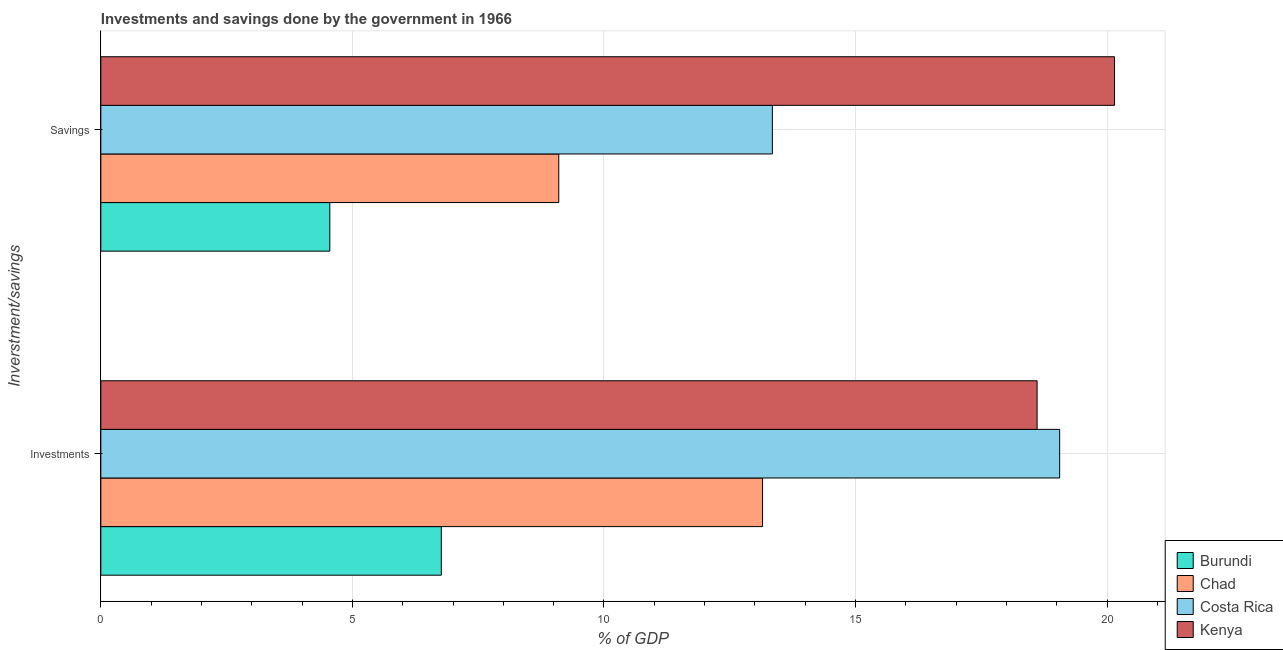How many different coloured bars are there?
Keep it short and to the point. 4. Are the number of bars per tick equal to the number of legend labels?
Keep it short and to the point. Yes. Are the number of bars on each tick of the Y-axis equal?
Provide a succinct answer. Yes. How many bars are there on the 1st tick from the bottom?
Make the answer very short. 4. What is the label of the 2nd group of bars from the top?
Offer a very short reply. Investments. What is the savings of government in Burundi?
Your response must be concise. 4.55. Across all countries, what is the maximum investments of government?
Offer a terse response. 19.06. Across all countries, what is the minimum investments of government?
Make the answer very short. 6.77. In which country was the investments of government maximum?
Your answer should be very brief. Costa Rica. In which country was the savings of government minimum?
Ensure brevity in your answer.  Burundi. What is the total investments of government in the graph?
Offer a very short reply. 57.59. What is the difference between the investments of government in Kenya and that in Burundi?
Give a very brief answer. 11.84. What is the difference between the investments of government in Burundi and the savings of government in Kenya?
Offer a very short reply. -13.38. What is the average investments of government per country?
Give a very brief answer. 14.4. What is the difference between the investments of government and savings of government in Kenya?
Give a very brief answer. -1.54. In how many countries, is the savings of government greater than 19 %?
Provide a short and direct response. 1. What is the ratio of the savings of government in Costa Rica to that in Burundi?
Your answer should be very brief. 2.93. What does the 4th bar from the top in Savings represents?
Ensure brevity in your answer.  Burundi. What does the 4th bar from the bottom in Savings represents?
Provide a short and direct response. Kenya. How many countries are there in the graph?
Your response must be concise. 4. What is the difference between two consecutive major ticks on the X-axis?
Offer a terse response. 5. Where does the legend appear in the graph?
Your answer should be compact. Bottom right. How many legend labels are there?
Your answer should be compact. 4. What is the title of the graph?
Provide a succinct answer. Investments and savings done by the government in 1966. What is the label or title of the X-axis?
Ensure brevity in your answer.  % of GDP. What is the label or title of the Y-axis?
Give a very brief answer. Inverstment/savings. What is the % of GDP of Burundi in Investments?
Your answer should be very brief. 6.77. What is the % of GDP of Chad in Investments?
Your response must be concise. 13.15. What is the % of GDP of Costa Rica in Investments?
Offer a very short reply. 19.06. What is the % of GDP of Kenya in Investments?
Your answer should be very brief. 18.61. What is the % of GDP of Burundi in Savings?
Provide a succinct answer. 4.55. What is the % of GDP in Chad in Savings?
Provide a succinct answer. 9.1. What is the % of GDP in Costa Rica in Savings?
Offer a very short reply. 13.35. What is the % of GDP of Kenya in Savings?
Your answer should be compact. 20.15. Across all Inverstment/savings, what is the maximum % of GDP in Burundi?
Your answer should be very brief. 6.77. Across all Inverstment/savings, what is the maximum % of GDP of Chad?
Provide a succinct answer. 13.15. Across all Inverstment/savings, what is the maximum % of GDP of Costa Rica?
Your answer should be very brief. 19.06. Across all Inverstment/savings, what is the maximum % of GDP in Kenya?
Make the answer very short. 20.15. Across all Inverstment/savings, what is the minimum % of GDP in Burundi?
Keep it short and to the point. 4.55. Across all Inverstment/savings, what is the minimum % of GDP of Chad?
Provide a short and direct response. 9.1. Across all Inverstment/savings, what is the minimum % of GDP in Costa Rica?
Provide a succinct answer. 13.35. Across all Inverstment/savings, what is the minimum % of GDP of Kenya?
Provide a succinct answer. 18.61. What is the total % of GDP of Burundi in the graph?
Keep it short and to the point. 11.32. What is the total % of GDP of Chad in the graph?
Offer a very short reply. 22.25. What is the total % of GDP in Costa Rica in the graph?
Keep it short and to the point. 32.41. What is the total % of GDP in Kenya in the graph?
Keep it short and to the point. 38.76. What is the difference between the % of GDP in Burundi in Investments and that in Savings?
Your response must be concise. 2.22. What is the difference between the % of GDP of Chad in Investments and that in Savings?
Make the answer very short. 4.05. What is the difference between the % of GDP of Costa Rica in Investments and that in Savings?
Provide a succinct answer. 5.71. What is the difference between the % of GDP in Kenya in Investments and that in Savings?
Provide a short and direct response. -1.54. What is the difference between the % of GDP in Burundi in Investments and the % of GDP in Chad in Savings?
Provide a succinct answer. -2.33. What is the difference between the % of GDP in Burundi in Investments and the % of GDP in Costa Rica in Savings?
Offer a very short reply. -6.58. What is the difference between the % of GDP in Burundi in Investments and the % of GDP in Kenya in Savings?
Offer a very short reply. -13.38. What is the difference between the % of GDP in Chad in Investments and the % of GDP in Costa Rica in Savings?
Offer a very short reply. -0.19. What is the difference between the % of GDP of Chad in Investments and the % of GDP of Kenya in Savings?
Provide a succinct answer. -7. What is the difference between the % of GDP of Costa Rica in Investments and the % of GDP of Kenya in Savings?
Provide a short and direct response. -1.09. What is the average % of GDP of Burundi per Inverstment/savings?
Provide a short and direct response. 5.66. What is the average % of GDP of Chad per Inverstment/savings?
Offer a very short reply. 11.13. What is the average % of GDP of Costa Rica per Inverstment/savings?
Keep it short and to the point. 16.2. What is the average % of GDP in Kenya per Inverstment/savings?
Make the answer very short. 19.38. What is the difference between the % of GDP of Burundi and % of GDP of Chad in Investments?
Give a very brief answer. -6.39. What is the difference between the % of GDP in Burundi and % of GDP in Costa Rica in Investments?
Your answer should be very brief. -12.29. What is the difference between the % of GDP of Burundi and % of GDP of Kenya in Investments?
Keep it short and to the point. -11.84. What is the difference between the % of GDP of Chad and % of GDP of Costa Rica in Investments?
Your answer should be compact. -5.91. What is the difference between the % of GDP of Chad and % of GDP of Kenya in Investments?
Your answer should be compact. -5.46. What is the difference between the % of GDP of Costa Rica and % of GDP of Kenya in Investments?
Ensure brevity in your answer.  0.45. What is the difference between the % of GDP of Burundi and % of GDP of Chad in Savings?
Offer a terse response. -4.55. What is the difference between the % of GDP of Burundi and % of GDP of Costa Rica in Savings?
Make the answer very short. -8.8. What is the difference between the % of GDP in Burundi and % of GDP in Kenya in Savings?
Your answer should be compact. -15.6. What is the difference between the % of GDP of Chad and % of GDP of Costa Rica in Savings?
Your response must be concise. -4.25. What is the difference between the % of GDP in Chad and % of GDP in Kenya in Savings?
Offer a very short reply. -11.05. What is the difference between the % of GDP in Costa Rica and % of GDP in Kenya in Savings?
Your answer should be compact. -6.8. What is the ratio of the % of GDP of Burundi in Investments to that in Savings?
Offer a terse response. 1.49. What is the ratio of the % of GDP in Chad in Investments to that in Savings?
Your answer should be compact. 1.45. What is the ratio of the % of GDP in Costa Rica in Investments to that in Savings?
Give a very brief answer. 1.43. What is the ratio of the % of GDP of Kenya in Investments to that in Savings?
Provide a succinct answer. 0.92. What is the difference between the highest and the second highest % of GDP in Burundi?
Make the answer very short. 2.22. What is the difference between the highest and the second highest % of GDP in Chad?
Offer a very short reply. 4.05. What is the difference between the highest and the second highest % of GDP of Costa Rica?
Offer a terse response. 5.71. What is the difference between the highest and the second highest % of GDP of Kenya?
Your answer should be very brief. 1.54. What is the difference between the highest and the lowest % of GDP in Burundi?
Offer a very short reply. 2.22. What is the difference between the highest and the lowest % of GDP of Chad?
Provide a succinct answer. 4.05. What is the difference between the highest and the lowest % of GDP of Costa Rica?
Ensure brevity in your answer.  5.71. What is the difference between the highest and the lowest % of GDP of Kenya?
Offer a terse response. 1.54. 